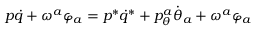Convert formula to latex. <formula><loc_0><loc_0><loc_500><loc_500>p \dot { q } + \omega ^ { a } \varphi _ { a } = p ^ { * } \dot { q } ^ { * } + p _ { \theta } ^ { a } \dot { \theta } _ { a } + \omega ^ { a } \varphi _ { a }</formula> 